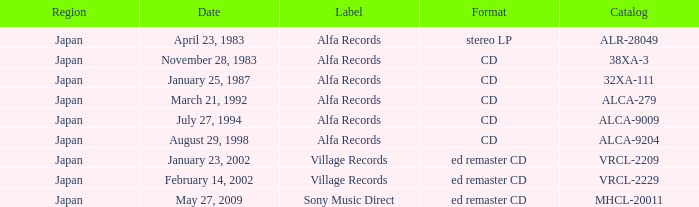Which catalog comes in the form of a cd? 38XA-3, 32XA-111, ALCA-279, ALCA-9009, ALCA-9204. 